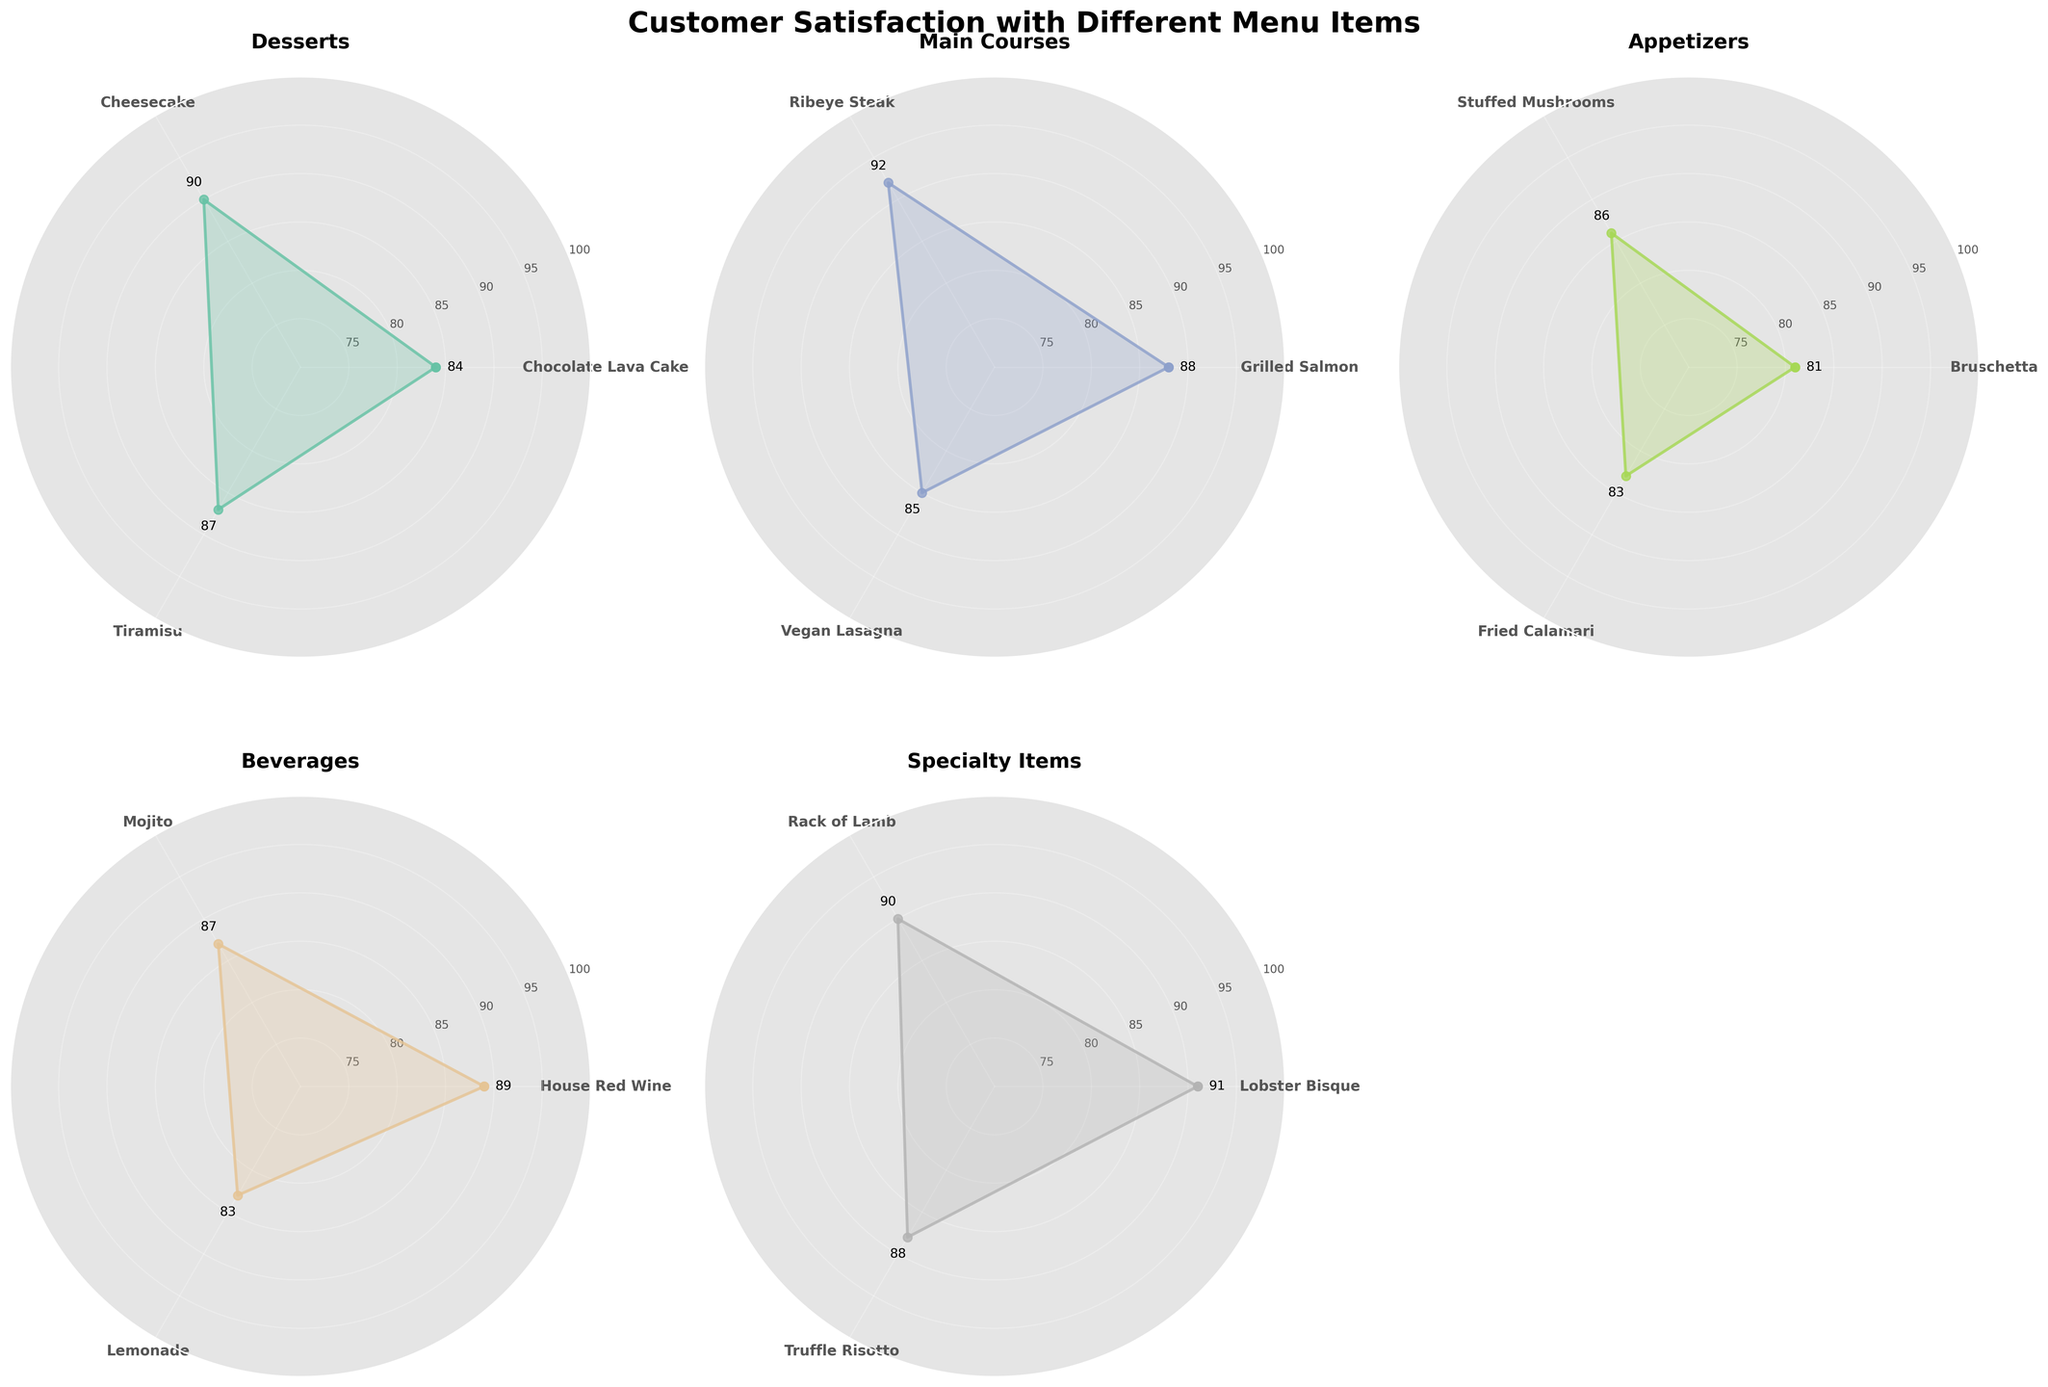Which dessert has the highest customer satisfaction? By looking at the plot under the "Desserts" category, it's clear that Cheesecake has the highest value among the items listed.
Answer: Cheesecake What is the difference in customer satisfaction between Ribeye Steak and Vegan Lasagna under Main Courses? The customer satisfaction for Ribeye Steak is 92 and for Vegan Lasagna is 85. The difference is 92 - 85 = 7.
Answer: 7 What are the customer satisfaction values for the beverages listed? Looking at the "Beverages" plot, the values are: House Red Wine (89), Mojito (87), and Lemonade (83).
Answer: 89, 87, 83 Which category has the most uniformly rated items in terms of customer satisfaction? By comparing the radar charts, the "Specialty Items" category has items with ratings very close to each other: Lobster Bisque (91), Rack of Lamb (90), and Truffle Risotto (88).
Answer: Specialty Items Which has higher customer satisfaction: Fried Calamari or Chocolate Lava Cake? The radar chart for "Appetizers" shows Fried Calamari with a satisfaction of 83, whereas "Desserts" shows Chocolate Lava Cake with a satisfaction of 84. Chocolate Lava Cake has a higher value.
Answer: Chocolate Lava Cake How does the customer satisfaction of Tiramisu compare to that of Mojito? From the radar charts, Tiramisu has a satisfaction of 87 and Mojito also has 87, so they have equal satisfaction.
Answer: Equal What is the average customer satisfaction for the items in the Appetizers category? The satisfaction values are Bruschetta (81), Stuffed Mushrooms (86), and Fried Calamari (83). The average is (81+86+83)/3 = 250/3 ≈ 83.33.
Answer: ≈ 83.33 Is there any item with a satisfaction rating above 90 in the Desserts category? By observing the "Desserts" radar chart, Cheesecake has a satisfaction rating of 90, but there are no items above 90.
Answer: No What is the maximum customer satisfaction value across all the categories? The highest individual value in all radar charts is 92 (Ribeye Steak in Main Courses).
Answer: 92 Which item has a higher customer satisfaction, House Red Wine or Rack of Lamb? From the radar charts: House Red Wine has a satisfaction value of 89, Rack of Lamb has 90. Rack of Lamb is higher.
Answer: Rack of Lamb 